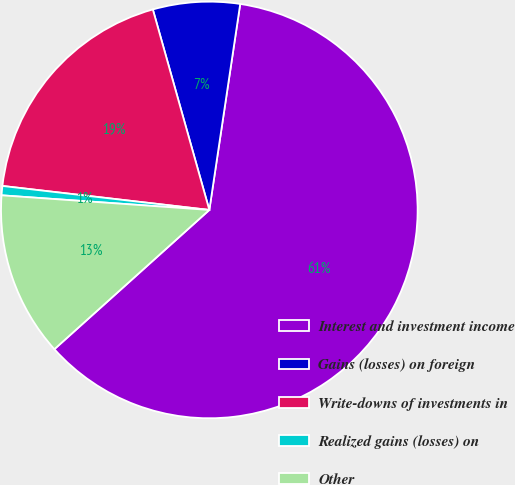Convert chart. <chart><loc_0><loc_0><loc_500><loc_500><pie_chart><fcel>Interest and investment income<fcel>Gains (losses) on foreign<fcel>Write-downs of investments in<fcel>Realized gains (losses) on<fcel>Other<nl><fcel>60.98%<fcel>6.74%<fcel>18.79%<fcel>0.72%<fcel>12.77%<nl></chart> 